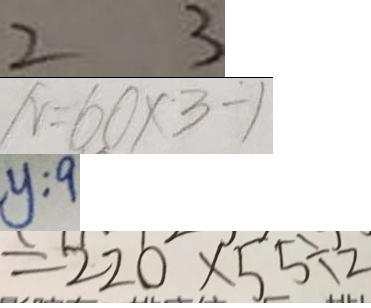Convert formula to latex. <formula><loc_0><loc_0><loc_500><loc_500>2 3 
 N = 6 0 \times 3 - 1 
 y : 9 
 = 2 2 0 \times 5 5 \div 2</formula> 